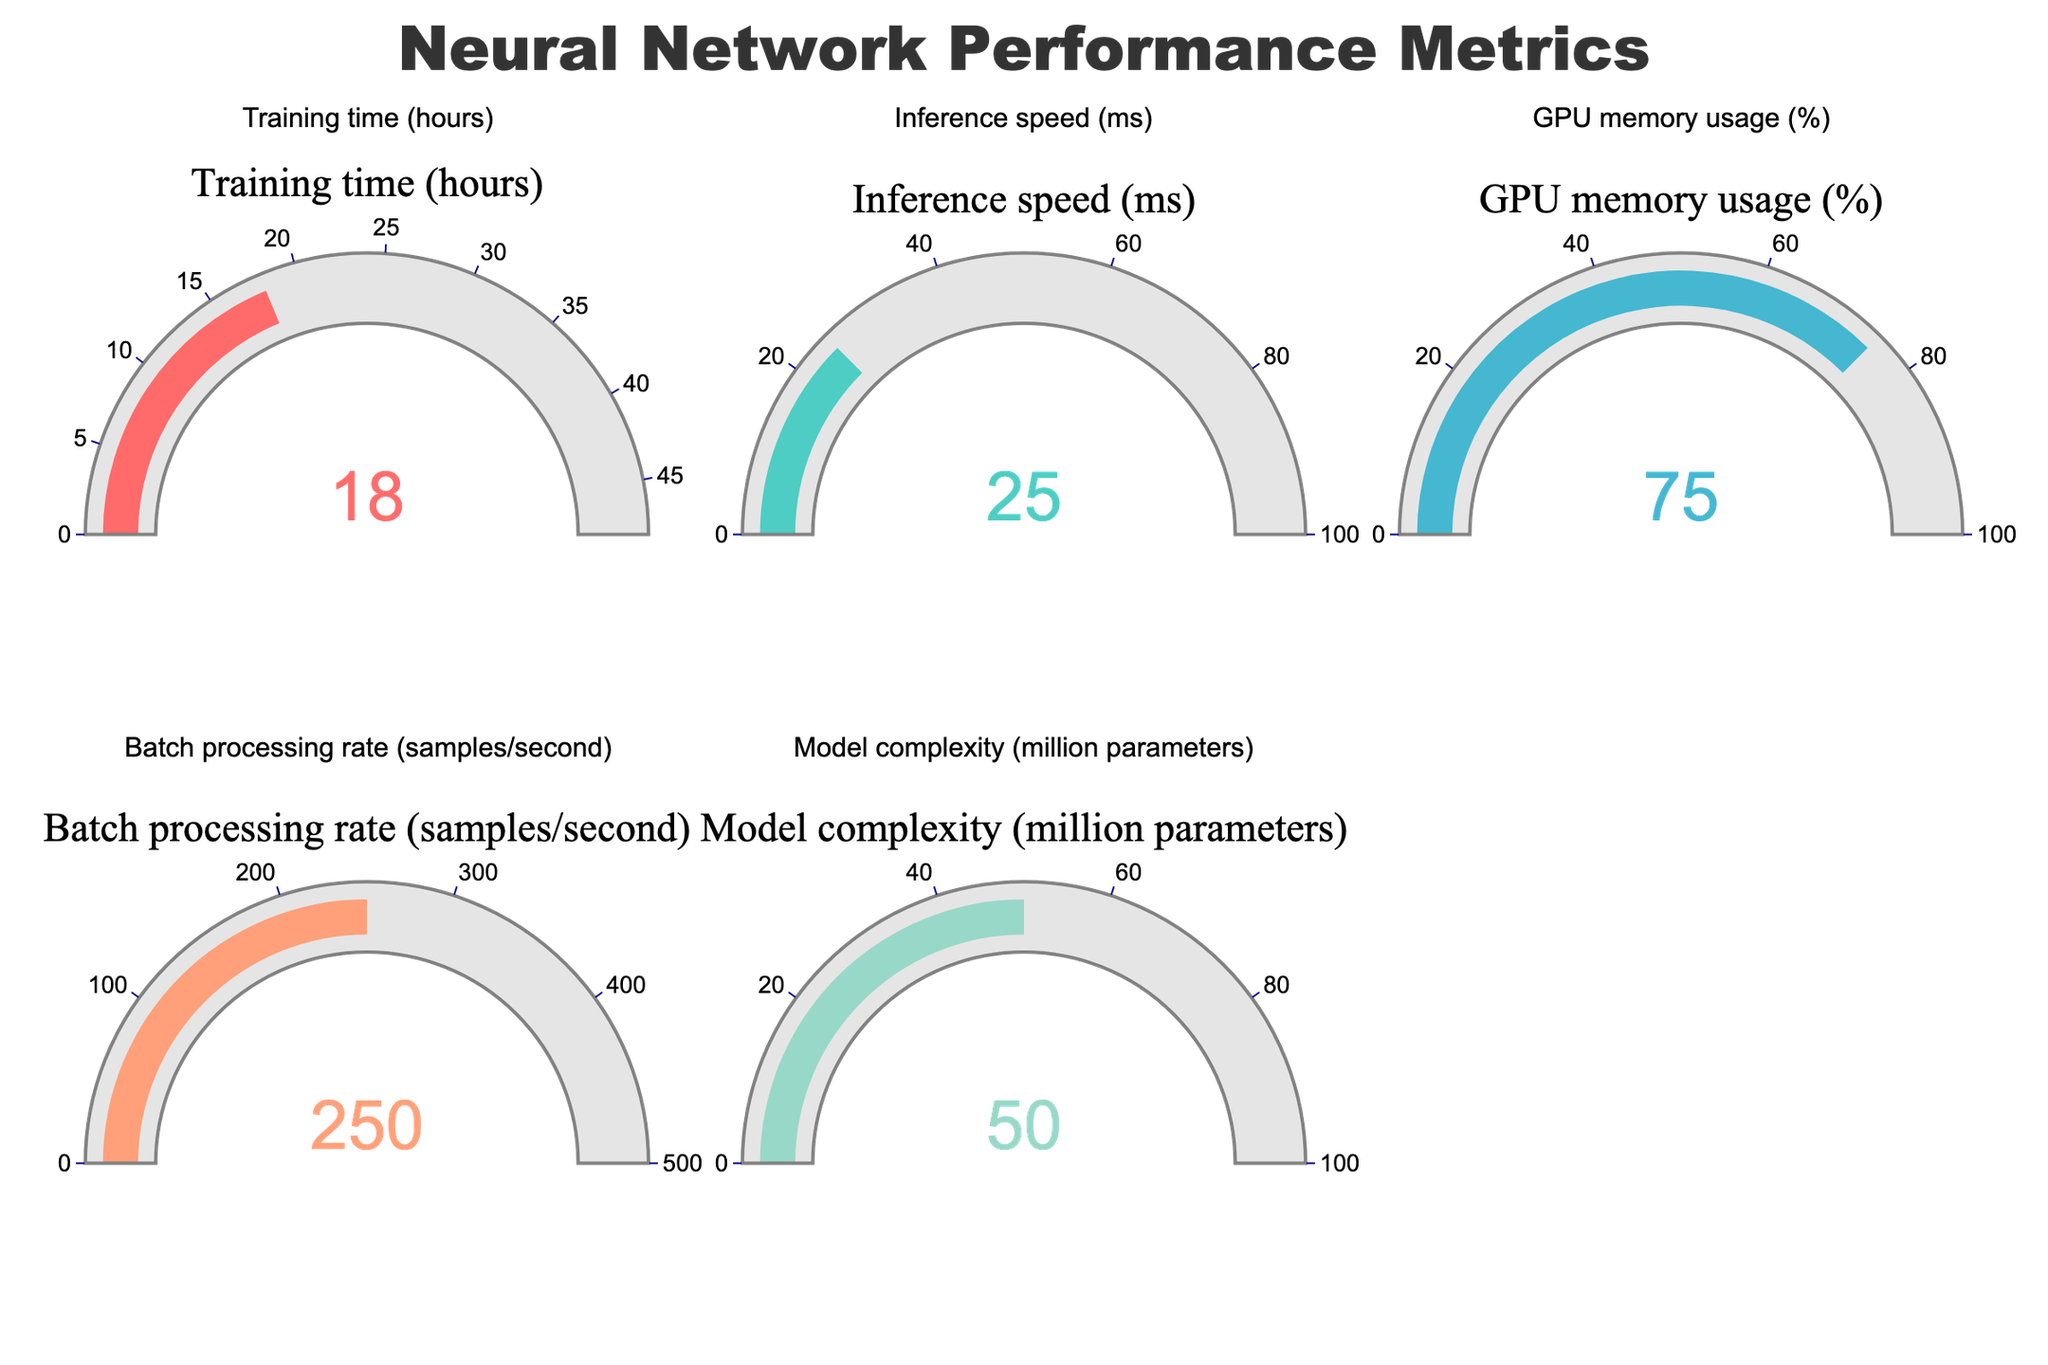What is the value for GPU memory usage in the gauge chart? Look at the gauge labeled "GPU memory usage" and read the number displayed on the gauge; it shows 75.
Answer: 75 How many metrics are displayed in the chart? Count the number of gauges, one for each metric. There are 5 gauges.
Answer: 5 What is the maximum possible value displayed for Training time? The gauge labeled "Training time (hours)" has a maximum value of 48, as indicated by its axis.
Answer: 48 Which metric has the highest maximum range on the gauge chart? Compare the maximum values shown on the axes of all the gauges. Batch processing rate has the highest maximum range of 500.
Answer: Batch processing rate Which metric has the smallest value on the gauge chart? Look at each gauge to identify the smallest value among them. Inference speed shows the smallest value at 25.
Answer: Inference speed What is the range of values for Model complexity? The range is given as the difference between the maximum and minimum values on the gauge axis for "Model complexity," which is 100 - 0 = 100.
Answer: 100 Compare the values of GPU memory usage and Batch processing rate. Which one is higher? Look at the individual gauges for both metrics. GPU memory usage is 75, and Batch processing rate is 250. The Batch processing rate value is higher.
Answer: Batch processing rate How much time does it take for inference in milliseconds? The gauge labeled "Inference speed (ms)" displays a value of 25.
Answer: 25 If we combine the values of Training time and Inference speed, what is the total? Add the values displayed on the "Training time (hours)" and "Inference speed (ms)" gauges: 18 + 25 = 43.
Answer: 43 Is the batch processing rate above the midpoint of its scale? The midpoint of the "Batch processing rate (samples/second)" scale is 250. The gauge displays a value of 250, which is exactly at the midpoint.
Answer: No 